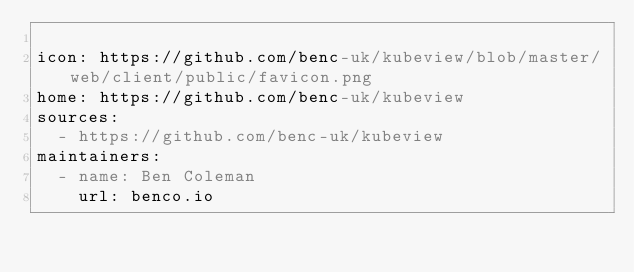<code> <loc_0><loc_0><loc_500><loc_500><_YAML_>
icon: https://github.com/benc-uk/kubeview/blob/master/web/client/public/favicon.png
home: https://github.com/benc-uk/kubeview
sources:
  - https://github.com/benc-uk/kubeview
maintainers:
  - name: Ben Coleman
    url: benco.io
</code> 